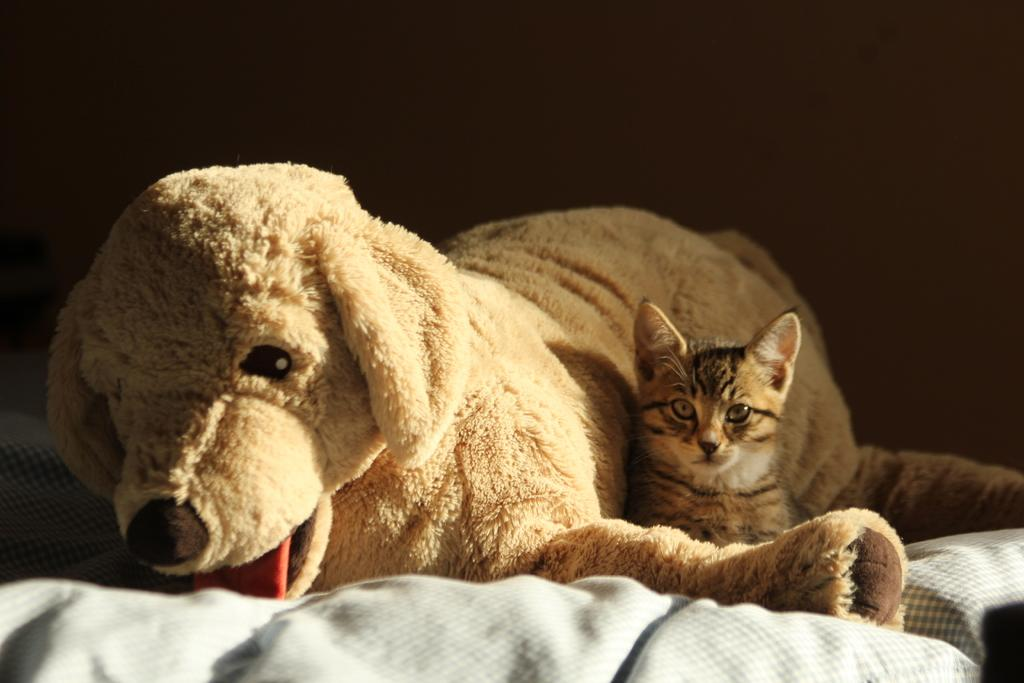What type of animal can be seen in the foreground of the image? There is a toy dog in the foreground of the image. What is the cat doing in the image? The cat is sitting on the bed in the image. How would you describe the lighting in the image? The background of the image is dark in color. Where was the image taken? The image was taken in a room. How many pizzas are visible on the cat's toes in the image? There are no pizzas or references to toes in the image; it features a toy dog in the foreground and a cat sitting on a bed. What color is the paint on the walls in the image? The image does not provide information about the color of the paint on the walls, as it focuses on the toy dog and cat in the room. 